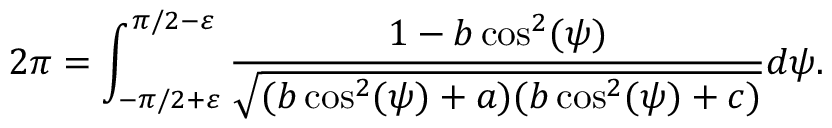Convert formula to latex. <formula><loc_0><loc_0><loc_500><loc_500>2 \pi = \int _ { - \pi / 2 + \varepsilon } ^ { \pi / 2 - \varepsilon } \frac { 1 - b \cos ^ { 2 } ( \psi ) } { \sqrt { ( b \cos ^ { 2 } ( \psi ) + a ) ( b \cos ^ { 2 } ( \psi ) + c ) } } d \psi .</formula> 